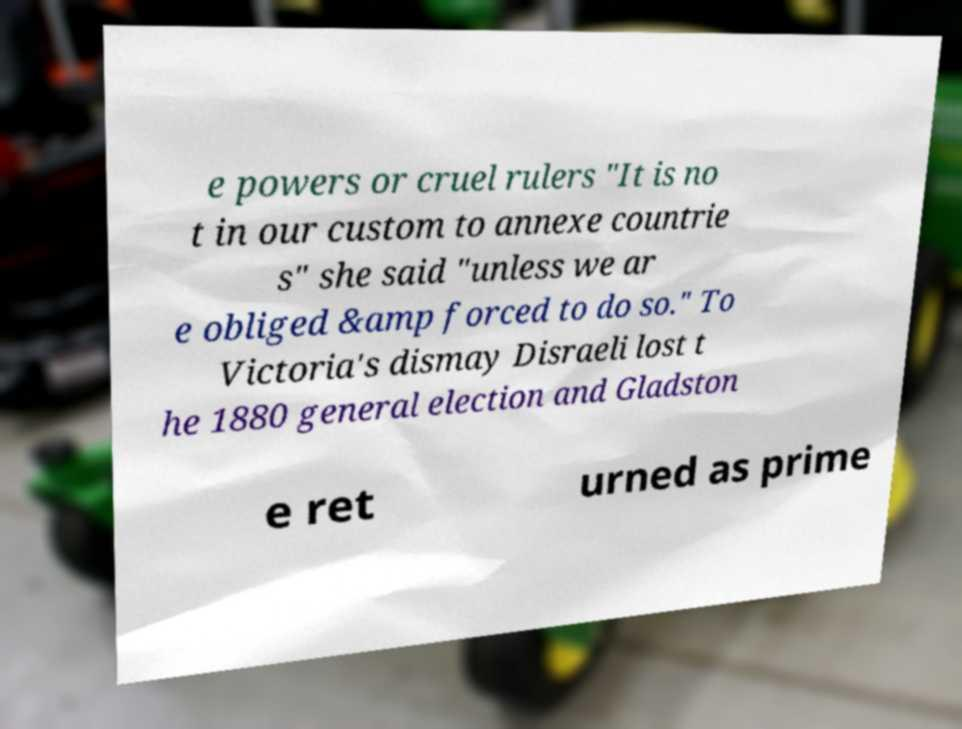There's text embedded in this image that I need extracted. Can you transcribe it verbatim? e powers or cruel rulers "It is no t in our custom to annexe countrie s" she said "unless we ar e obliged &amp forced to do so." To Victoria's dismay Disraeli lost t he 1880 general election and Gladston e ret urned as prime 